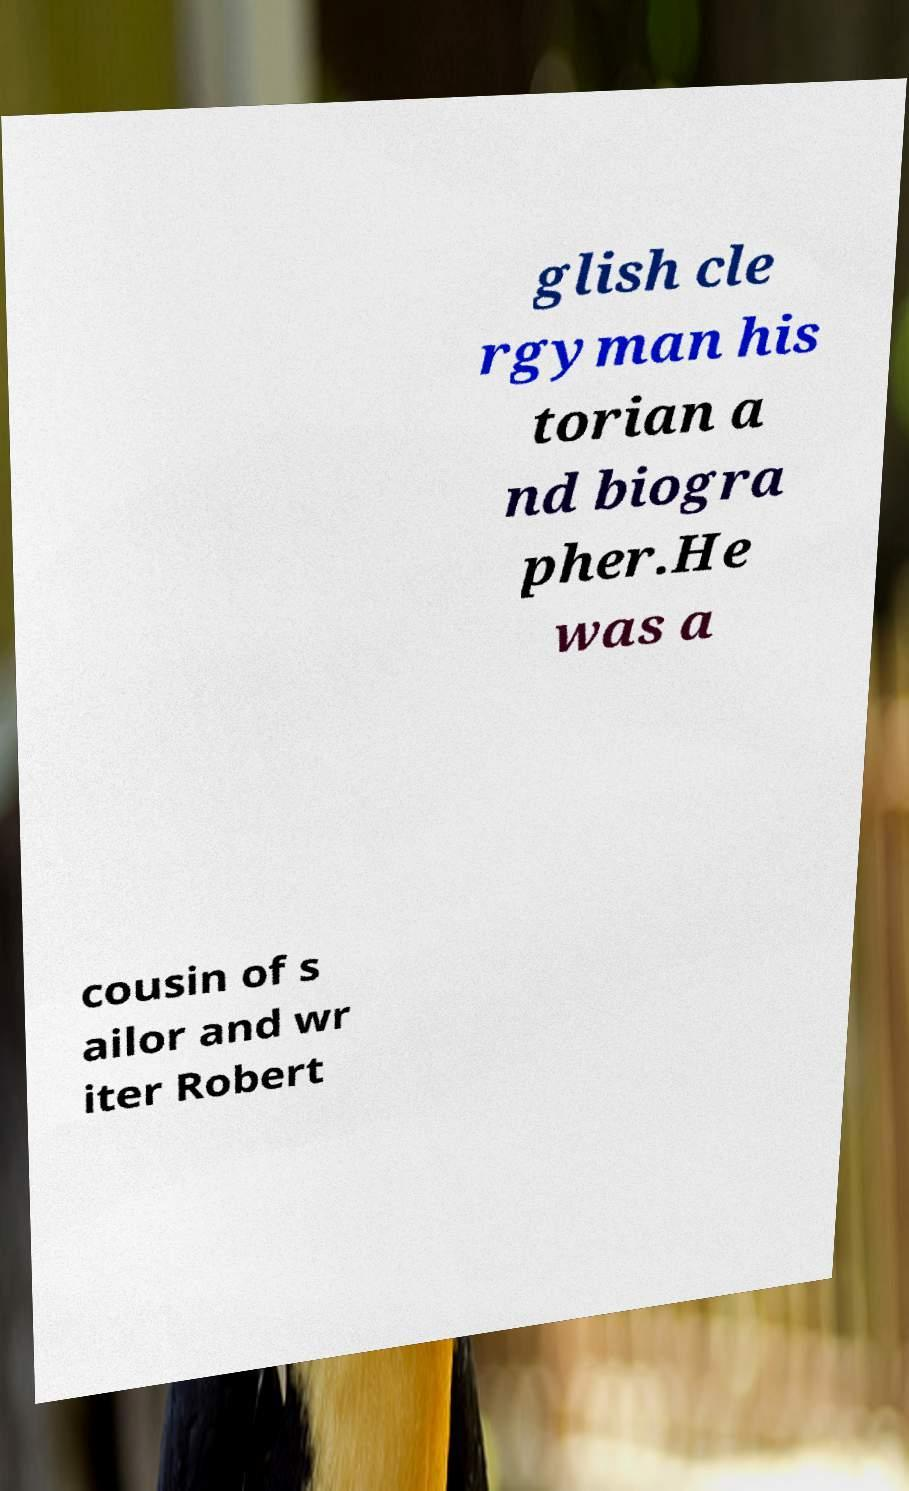Could you extract and type out the text from this image? glish cle rgyman his torian a nd biogra pher.He was a cousin of s ailor and wr iter Robert 